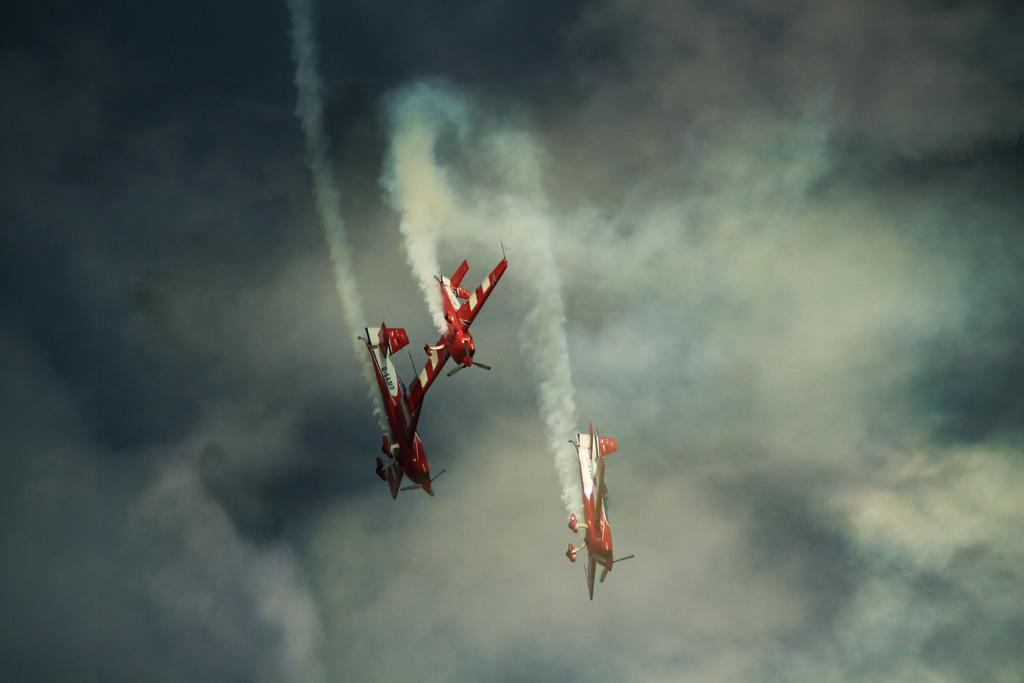How many aircraft are visible in the image? There are three red color aircraft in the image. What are the aircraft doing in the image? The aircraft are flying in the air. What can be observed coming out of the aircraft? The aircraft are emitting smoke. What is visible in the background of the image? There are clouds in the sky in the background of the image. What historical event is being depicted in the image? The image does not depict any historical event; it shows three red color aircraft flying in the air and emitting smoke. Can you tell me where the nearest harbor is in the image? There is no harbor present in the image; it features aircraft flying in the sky. 